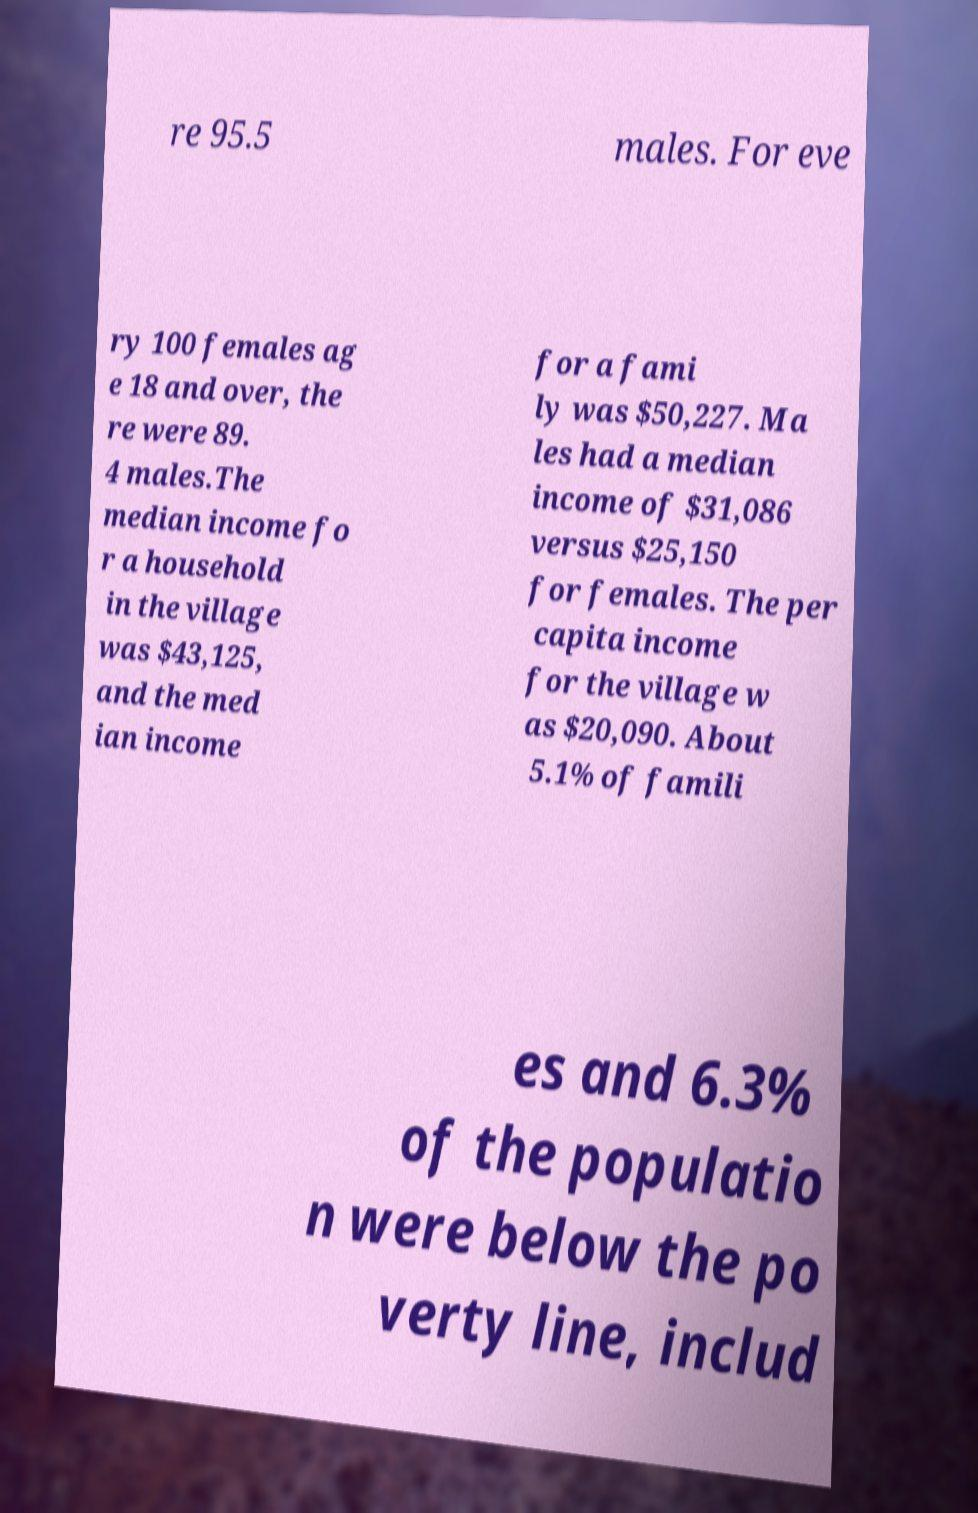Can you read and provide the text displayed in the image?This photo seems to have some interesting text. Can you extract and type it out for me? re 95.5 males. For eve ry 100 females ag e 18 and over, the re were 89. 4 males.The median income fo r a household in the village was $43,125, and the med ian income for a fami ly was $50,227. Ma les had a median income of $31,086 versus $25,150 for females. The per capita income for the village w as $20,090. About 5.1% of famili es and 6.3% of the populatio n were below the po verty line, includ 